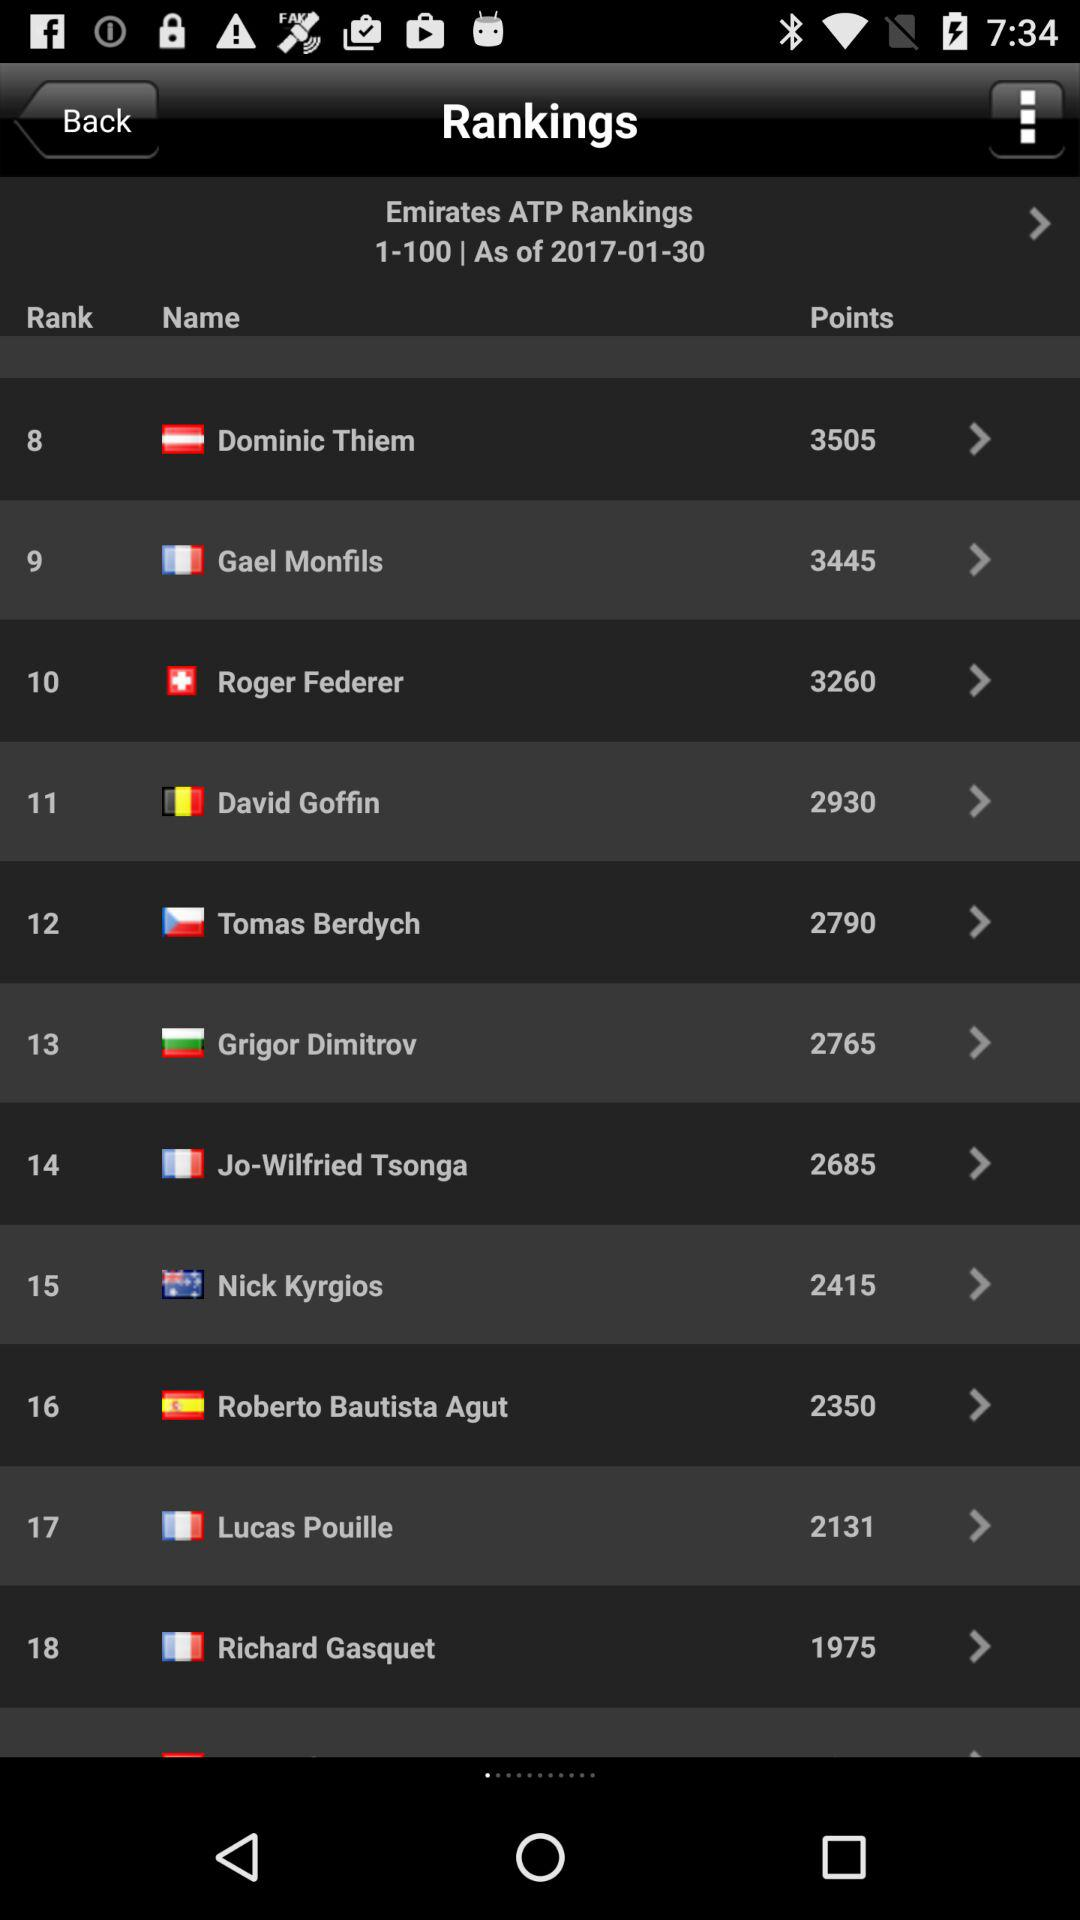Who is ranked #1 as of January 31, 2017?
When the provided information is insufficient, respond with <no answer>. <no answer> 